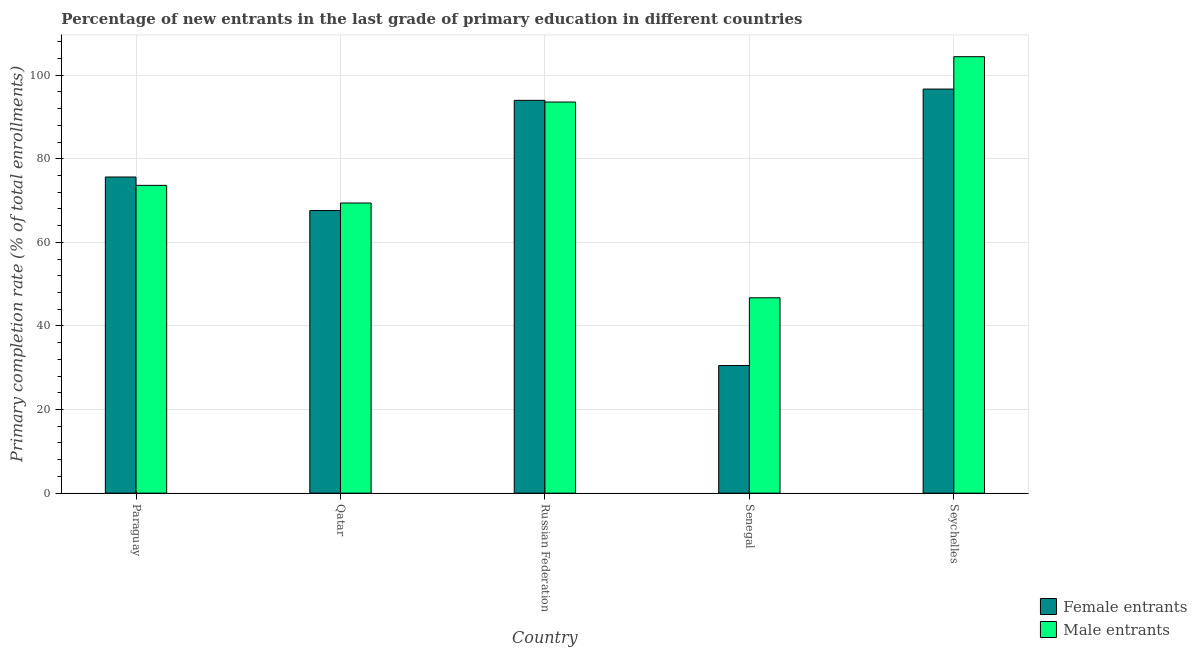How many different coloured bars are there?
Your answer should be very brief. 2. Are the number of bars per tick equal to the number of legend labels?
Give a very brief answer. Yes. Are the number of bars on each tick of the X-axis equal?
Provide a short and direct response. Yes. What is the label of the 5th group of bars from the left?
Your response must be concise. Seychelles. In how many cases, is the number of bars for a given country not equal to the number of legend labels?
Provide a succinct answer. 0. What is the primary completion rate of female entrants in Qatar?
Provide a succinct answer. 67.61. Across all countries, what is the maximum primary completion rate of male entrants?
Your answer should be very brief. 104.42. Across all countries, what is the minimum primary completion rate of female entrants?
Offer a very short reply. 30.53. In which country was the primary completion rate of male entrants maximum?
Provide a succinct answer. Seychelles. In which country was the primary completion rate of female entrants minimum?
Offer a very short reply. Senegal. What is the total primary completion rate of female entrants in the graph?
Give a very brief answer. 364.44. What is the difference between the primary completion rate of male entrants in Senegal and that in Seychelles?
Offer a very short reply. -57.68. What is the difference between the primary completion rate of female entrants in Senegal and the primary completion rate of male entrants in Qatar?
Give a very brief answer. -38.89. What is the average primary completion rate of female entrants per country?
Give a very brief answer. 72.89. What is the difference between the primary completion rate of male entrants and primary completion rate of female entrants in Senegal?
Offer a terse response. 16.21. In how many countries, is the primary completion rate of male entrants greater than 40 %?
Your answer should be very brief. 5. What is the ratio of the primary completion rate of female entrants in Qatar to that in Senegal?
Your answer should be very brief. 2.21. Is the primary completion rate of female entrants in Qatar less than that in Seychelles?
Give a very brief answer. Yes. Is the difference between the primary completion rate of male entrants in Qatar and Russian Federation greater than the difference between the primary completion rate of female entrants in Qatar and Russian Federation?
Offer a terse response. Yes. What is the difference between the highest and the second highest primary completion rate of female entrants?
Provide a succinct answer. 2.7. What is the difference between the highest and the lowest primary completion rate of female entrants?
Your answer should be compact. 66.15. Is the sum of the primary completion rate of male entrants in Paraguay and Qatar greater than the maximum primary completion rate of female entrants across all countries?
Give a very brief answer. Yes. What does the 1st bar from the left in Paraguay represents?
Make the answer very short. Female entrants. What does the 1st bar from the right in Seychelles represents?
Provide a succinct answer. Male entrants. What is the difference between two consecutive major ticks on the Y-axis?
Your answer should be very brief. 20. Are the values on the major ticks of Y-axis written in scientific E-notation?
Your answer should be very brief. No. Does the graph contain any zero values?
Give a very brief answer. No. Does the graph contain grids?
Ensure brevity in your answer.  Yes. Where does the legend appear in the graph?
Keep it short and to the point. Bottom right. What is the title of the graph?
Your response must be concise. Percentage of new entrants in the last grade of primary education in different countries. What is the label or title of the X-axis?
Provide a short and direct response. Country. What is the label or title of the Y-axis?
Your answer should be compact. Primary completion rate (% of total enrollments). What is the Primary completion rate (% of total enrollments) in Female entrants in Paraguay?
Ensure brevity in your answer.  75.64. What is the Primary completion rate (% of total enrollments) of Male entrants in Paraguay?
Offer a very short reply. 73.64. What is the Primary completion rate (% of total enrollments) in Female entrants in Qatar?
Make the answer very short. 67.61. What is the Primary completion rate (% of total enrollments) of Male entrants in Qatar?
Offer a very short reply. 69.42. What is the Primary completion rate (% of total enrollments) of Female entrants in Russian Federation?
Ensure brevity in your answer.  93.98. What is the Primary completion rate (% of total enrollments) in Male entrants in Russian Federation?
Provide a short and direct response. 93.57. What is the Primary completion rate (% of total enrollments) of Female entrants in Senegal?
Your response must be concise. 30.53. What is the Primary completion rate (% of total enrollments) of Male entrants in Senegal?
Give a very brief answer. 46.74. What is the Primary completion rate (% of total enrollments) of Female entrants in Seychelles?
Keep it short and to the point. 96.68. What is the Primary completion rate (% of total enrollments) in Male entrants in Seychelles?
Make the answer very short. 104.42. Across all countries, what is the maximum Primary completion rate (% of total enrollments) of Female entrants?
Ensure brevity in your answer.  96.68. Across all countries, what is the maximum Primary completion rate (% of total enrollments) in Male entrants?
Your answer should be very brief. 104.42. Across all countries, what is the minimum Primary completion rate (% of total enrollments) of Female entrants?
Make the answer very short. 30.53. Across all countries, what is the minimum Primary completion rate (% of total enrollments) in Male entrants?
Provide a short and direct response. 46.74. What is the total Primary completion rate (% of total enrollments) of Female entrants in the graph?
Offer a terse response. 364.44. What is the total Primary completion rate (% of total enrollments) in Male entrants in the graph?
Make the answer very short. 387.8. What is the difference between the Primary completion rate (% of total enrollments) of Female entrants in Paraguay and that in Qatar?
Ensure brevity in your answer.  8.03. What is the difference between the Primary completion rate (% of total enrollments) of Male entrants in Paraguay and that in Qatar?
Give a very brief answer. 4.22. What is the difference between the Primary completion rate (% of total enrollments) in Female entrants in Paraguay and that in Russian Federation?
Your answer should be very brief. -18.34. What is the difference between the Primary completion rate (% of total enrollments) of Male entrants in Paraguay and that in Russian Federation?
Offer a very short reply. -19.93. What is the difference between the Primary completion rate (% of total enrollments) in Female entrants in Paraguay and that in Senegal?
Provide a succinct answer. 45.11. What is the difference between the Primary completion rate (% of total enrollments) in Male entrants in Paraguay and that in Senegal?
Your answer should be compact. 26.9. What is the difference between the Primary completion rate (% of total enrollments) of Female entrants in Paraguay and that in Seychelles?
Keep it short and to the point. -21.04. What is the difference between the Primary completion rate (% of total enrollments) of Male entrants in Paraguay and that in Seychelles?
Give a very brief answer. -30.78. What is the difference between the Primary completion rate (% of total enrollments) of Female entrants in Qatar and that in Russian Federation?
Your answer should be compact. -26.37. What is the difference between the Primary completion rate (% of total enrollments) of Male entrants in Qatar and that in Russian Federation?
Make the answer very short. -24.16. What is the difference between the Primary completion rate (% of total enrollments) in Female entrants in Qatar and that in Senegal?
Your response must be concise. 37.08. What is the difference between the Primary completion rate (% of total enrollments) in Male entrants in Qatar and that in Senegal?
Offer a terse response. 22.67. What is the difference between the Primary completion rate (% of total enrollments) of Female entrants in Qatar and that in Seychelles?
Give a very brief answer. -29.07. What is the difference between the Primary completion rate (% of total enrollments) in Male entrants in Qatar and that in Seychelles?
Provide a succinct answer. -35.01. What is the difference between the Primary completion rate (% of total enrollments) in Female entrants in Russian Federation and that in Senegal?
Your response must be concise. 63.45. What is the difference between the Primary completion rate (% of total enrollments) in Male entrants in Russian Federation and that in Senegal?
Keep it short and to the point. 46.83. What is the difference between the Primary completion rate (% of total enrollments) of Female entrants in Russian Federation and that in Seychelles?
Provide a succinct answer. -2.7. What is the difference between the Primary completion rate (% of total enrollments) of Male entrants in Russian Federation and that in Seychelles?
Keep it short and to the point. -10.85. What is the difference between the Primary completion rate (% of total enrollments) of Female entrants in Senegal and that in Seychelles?
Keep it short and to the point. -66.15. What is the difference between the Primary completion rate (% of total enrollments) of Male entrants in Senegal and that in Seychelles?
Provide a succinct answer. -57.68. What is the difference between the Primary completion rate (% of total enrollments) of Female entrants in Paraguay and the Primary completion rate (% of total enrollments) of Male entrants in Qatar?
Offer a very short reply. 6.22. What is the difference between the Primary completion rate (% of total enrollments) in Female entrants in Paraguay and the Primary completion rate (% of total enrollments) in Male entrants in Russian Federation?
Your response must be concise. -17.94. What is the difference between the Primary completion rate (% of total enrollments) in Female entrants in Paraguay and the Primary completion rate (% of total enrollments) in Male entrants in Senegal?
Your answer should be compact. 28.89. What is the difference between the Primary completion rate (% of total enrollments) of Female entrants in Paraguay and the Primary completion rate (% of total enrollments) of Male entrants in Seychelles?
Provide a short and direct response. -28.79. What is the difference between the Primary completion rate (% of total enrollments) in Female entrants in Qatar and the Primary completion rate (% of total enrollments) in Male entrants in Russian Federation?
Keep it short and to the point. -25.96. What is the difference between the Primary completion rate (% of total enrollments) of Female entrants in Qatar and the Primary completion rate (% of total enrollments) of Male entrants in Senegal?
Keep it short and to the point. 20.87. What is the difference between the Primary completion rate (% of total enrollments) of Female entrants in Qatar and the Primary completion rate (% of total enrollments) of Male entrants in Seychelles?
Your answer should be compact. -36.81. What is the difference between the Primary completion rate (% of total enrollments) of Female entrants in Russian Federation and the Primary completion rate (% of total enrollments) of Male entrants in Senegal?
Give a very brief answer. 47.24. What is the difference between the Primary completion rate (% of total enrollments) of Female entrants in Russian Federation and the Primary completion rate (% of total enrollments) of Male entrants in Seychelles?
Your response must be concise. -10.44. What is the difference between the Primary completion rate (% of total enrollments) in Female entrants in Senegal and the Primary completion rate (% of total enrollments) in Male entrants in Seychelles?
Your answer should be compact. -73.89. What is the average Primary completion rate (% of total enrollments) of Female entrants per country?
Ensure brevity in your answer.  72.89. What is the average Primary completion rate (% of total enrollments) of Male entrants per country?
Your answer should be compact. 77.56. What is the difference between the Primary completion rate (% of total enrollments) of Female entrants and Primary completion rate (% of total enrollments) of Male entrants in Paraguay?
Offer a terse response. 2. What is the difference between the Primary completion rate (% of total enrollments) of Female entrants and Primary completion rate (% of total enrollments) of Male entrants in Qatar?
Your answer should be compact. -1.81. What is the difference between the Primary completion rate (% of total enrollments) of Female entrants and Primary completion rate (% of total enrollments) of Male entrants in Russian Federation?
Your answer should be compact. 0.41. What is the difference between the Primary completion rate (% of total enrollments) of Female entrants and Primary completion rate (% of total enrollments) of Male entrants in Senegal?
Keep it short and to the point. -16.21. What is the difference between the Primary completion rate (% of total enrollments) of Female entrants and Primary completion rate (% of total enrollments) of Male entrants in Seychelles?
Your answer should be compact. -7.74. What is the ratio of the Primary completion rate (% of total enrollments) of Female entrants in Paraguay to that in Qatar?
Keep it short and to the point. 1.12. What is the ratio of the Primary completion rate (% of total enrollments) in Male entrants in Paraguay to that in Qatar?
Your answer should be very brief. 1.06. What is the ratio of the Primary completion rate (% of total enrollments) in Female entrants in Paraguay to that in Russian Federation?
Offer a very short reply. 0.8. What is the ratio of the Primary completion rate (% of total enrollments) in Male entrants in Paraguay to that in Russian Federation?
Make the answer very short. 0.79. What is the ratio of the Primary completion rate (% of total enrollments) of Female entrants in Paraguay to that in Senegal?
Your answer should be compact. 2.48. What is the ratio of the Primary completion rate (% of total enrollments) in Male entrants in Paraguay to that in Senegal?
Keep it short and to the point. 1.58. What is the ratio of the Primary completion rate (% of total enrollments) of Female entrants in Paraguay to that in Seychelles?
Your answer should be very brief. 0.78. What is the ratio of the Primary completion rate (% of total enrollments) in Male entrants in Paraguay to that in Seychelles?
Make the answer very short. 0.71. What is the ratio of the Primary completion rate (% of total enrollments) in Female entrants in Qatar to that in Russian Federation?
Your answer should be very brief. 0.72. What is the ratio of the Primary completion rate (% of total enrollments) of Male entrants in Qatar to that in Russian Federation?
Offer a terse response. 0.74. What is the ratio of the Primary completion rate (% of total enrollments) of Female entrants in Qatar to that in Senegal?
Ensure brevity in your answer.  2.21. What is the ratio of the Primary completion rate (% of total enrollments) in Male entrants in Qatar to that in Senegal?
Your answer should be compact. 1.49. What is the ratio of the Primary completion rate (% of total enrollments) in Female entrants in Qatar to that in Seychelles?
Keep it short and to the point. 0.7. What is the ratio of the Primary completion rate (% of total enrollments) of Male entrants in Qatar to that in Seychelles?
Give a very brief answer. 0.66. What is the ratio of the Primary completion rate (% of total enrollments) in Female entrants in Russian Federation to that in Senegal?
Ensure brevity in your answer.  3.08. What is the ratio of the Primary completion rate (% of total enrollments) in Male entrants in Russian Federation to that in Senegal?
Keep it short and to the point. 2. What is the ratio of the Primary completion rate (% of total enrollments) in Female entrants in Russian Federation to that in Seychelles?
Offer a very short reply. 0.97. What is the ratio of the Primary completion rate (% of total enrollments) of Male entrants in Russian Federation to that in Seychelles?
Your answer should be very brief. 0.9. What is the ratio of the Primary completion rate (% of total enrollments) in Female entrants in Senegal to that in Seychelles?
Give a very brief answer. 0.32. What is the ratio of the Primary completion rate (% of total enrollments) of Male entrants in Senegal to that in Seychelles?
Provide a short and direct response. 0.45. What is the difference between the highest and the second highest Primary completion rate (% of total enrollments) of Female entrants?
Offer a very short reply. 2.7. What is the difference between the highest and the second highest Primary completion rate (% of total enrollments) in Male entrants?
Provide a succinct answer. 10.85. What is the difference between the highest and the lowest Primary completion rate (% of total enrollments) of Female entrants?
Offer a terse response. 66.15. What is the difference between the highest and the lowest Primary completion rate (% of total enrollments) in Male entrants?
Make the answer very short. 57.68. 